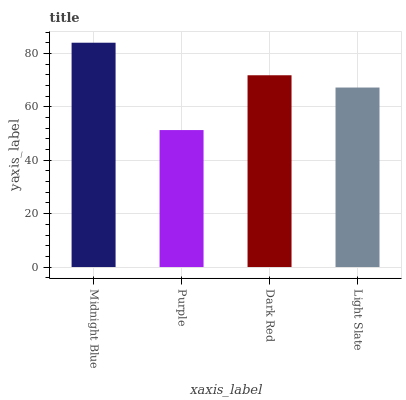Is Purple the minimum?
Answer yes or no. Yes. Is Midnight Blue the maximum?
Answer yes or no. Yes. Is Dark Red the minimum?
Answer yes or no. No. Is Dark Red the maximum?
Answer yes or no. No. Is Dark Red greater than Purple?
Answer yes or no. Yes. Is Purple less than Dark Red?
Answer yes or no. Yes. Is Purple greater than Dark Red?
Answer yes or no. No. Is Dark Red less than Purple?
Answer yes or no. No. Is Dark Red the high median?
Answer yes or no. Yes. Is Light Slate the low median?
Answer yes or no. Yes. Is Midnight Blue the high median?
Answer yes or no. No. Is Purple the low median?
Answer yes or no. No. 